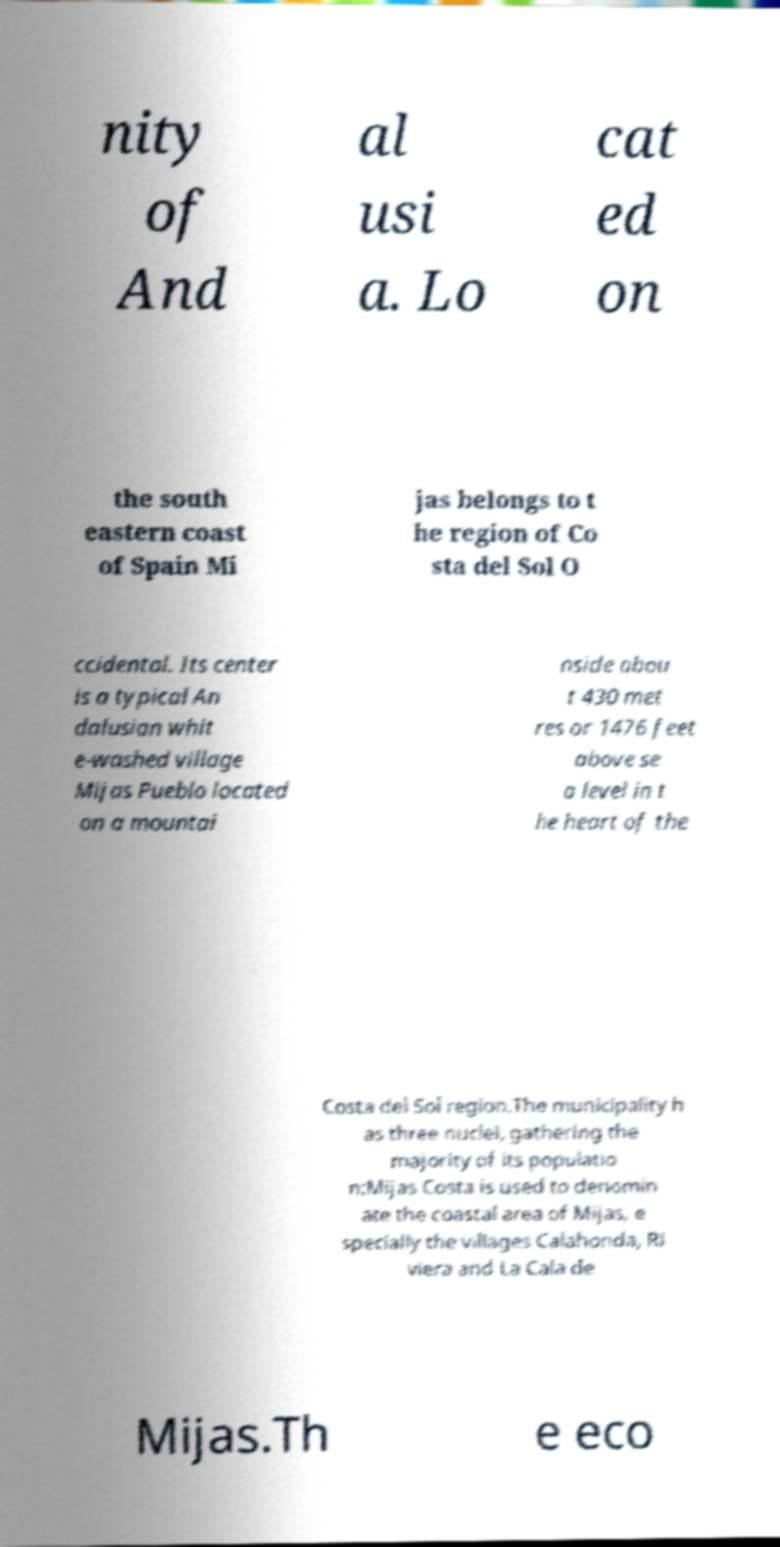Please identify and transcribe the text found in this image. nity of And al usi a. Lo cat ed on the south eastern coast of Spain Mi jas belongs to t he region of Co sta del Sol O ccidental. Its center is a typical An dalusian whit e-washed village Mijas Pueblo located on a mountai nside abou t 430 met res or 1476 feet above se a level in t he heart of the Costa del Sol region.The municipality h as three nuclei, gathering the majority of its populatio n:Mijas Costa is used to denomin ate the coastal area of Mijas, e specially the villages Calahonda, Ri viera and La Cala de Mijas.Th e eco 